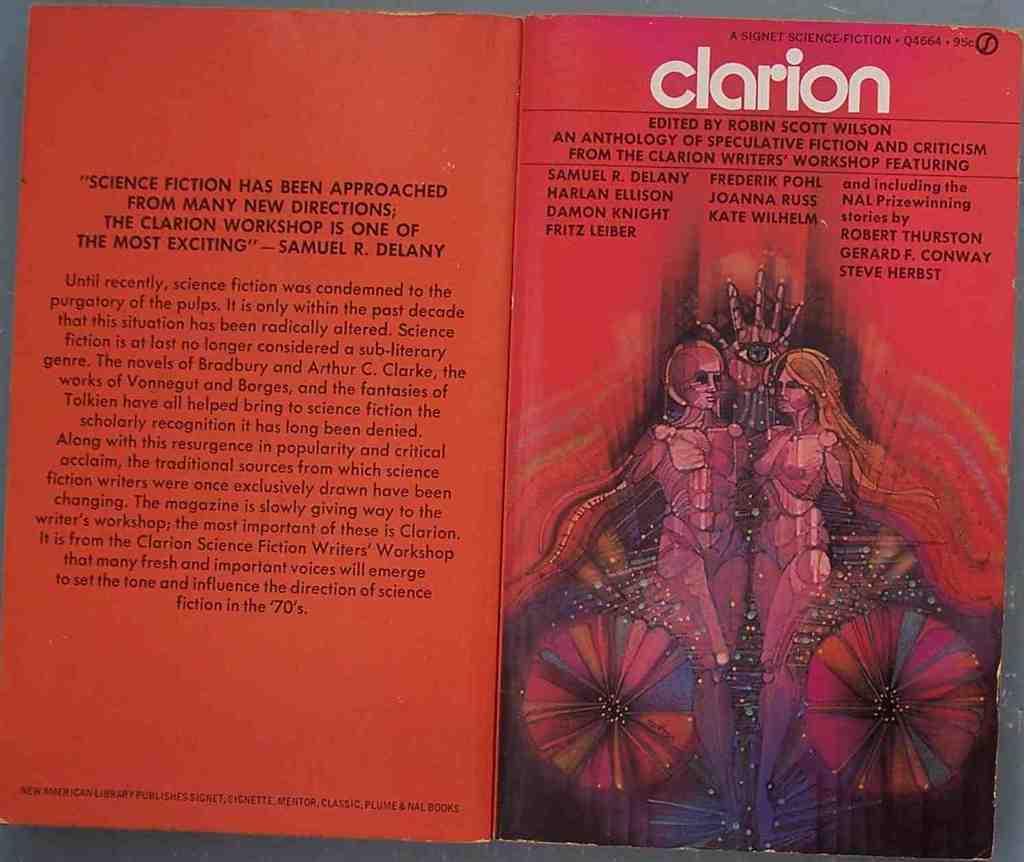Who is this edited by?
Ensure brevity in your answer.  Robin scott wilson. What is the word in white text?
Your answer should be compact. Clarion. 